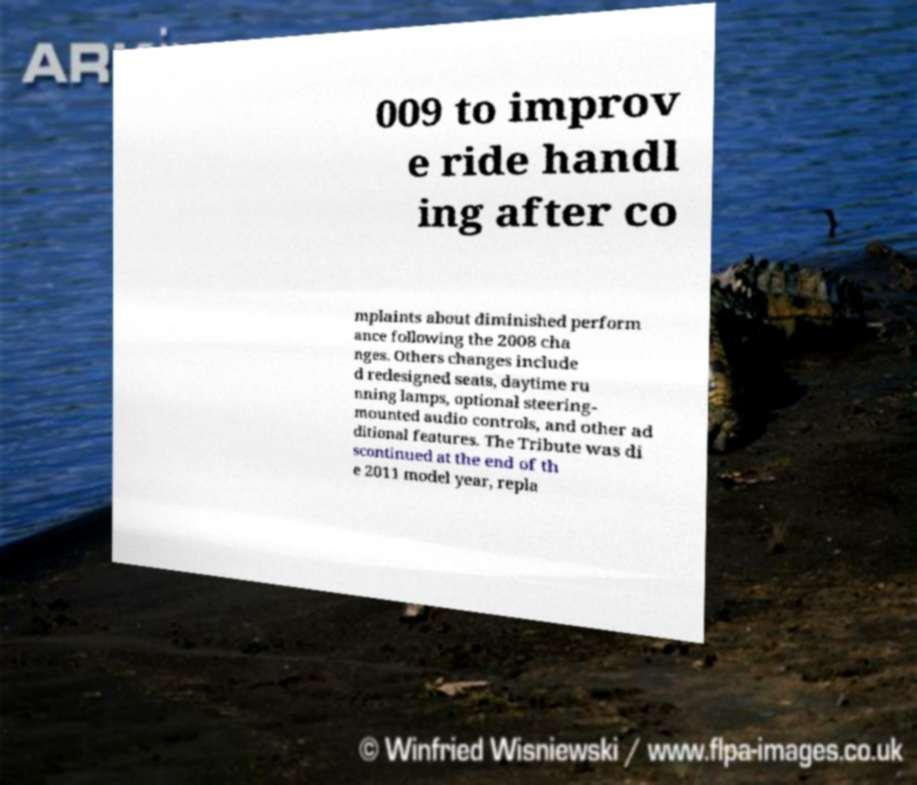I need the written content from this picture converted into text. Can you do that? 009 to improv e ride handl ing after co mplaints about diminished perform ance following the 2008 cha nges. Others changes include d redesigned seats, daytime ru nning lamps, optional steering- mounted audio controls, and other ad ditional features. The Tribute was di scontinued at the end of th e 2011 model year, repla 